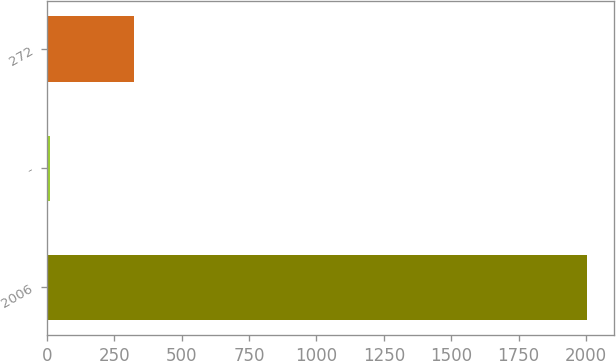<chart> <loc_0><loc_0><loc_500><loc_500><bar_chart><fcel>2006<fcel>-<fcel>272<nl><fcel>2004<fcel>10.3<fcel>322.2<nl></chart> 